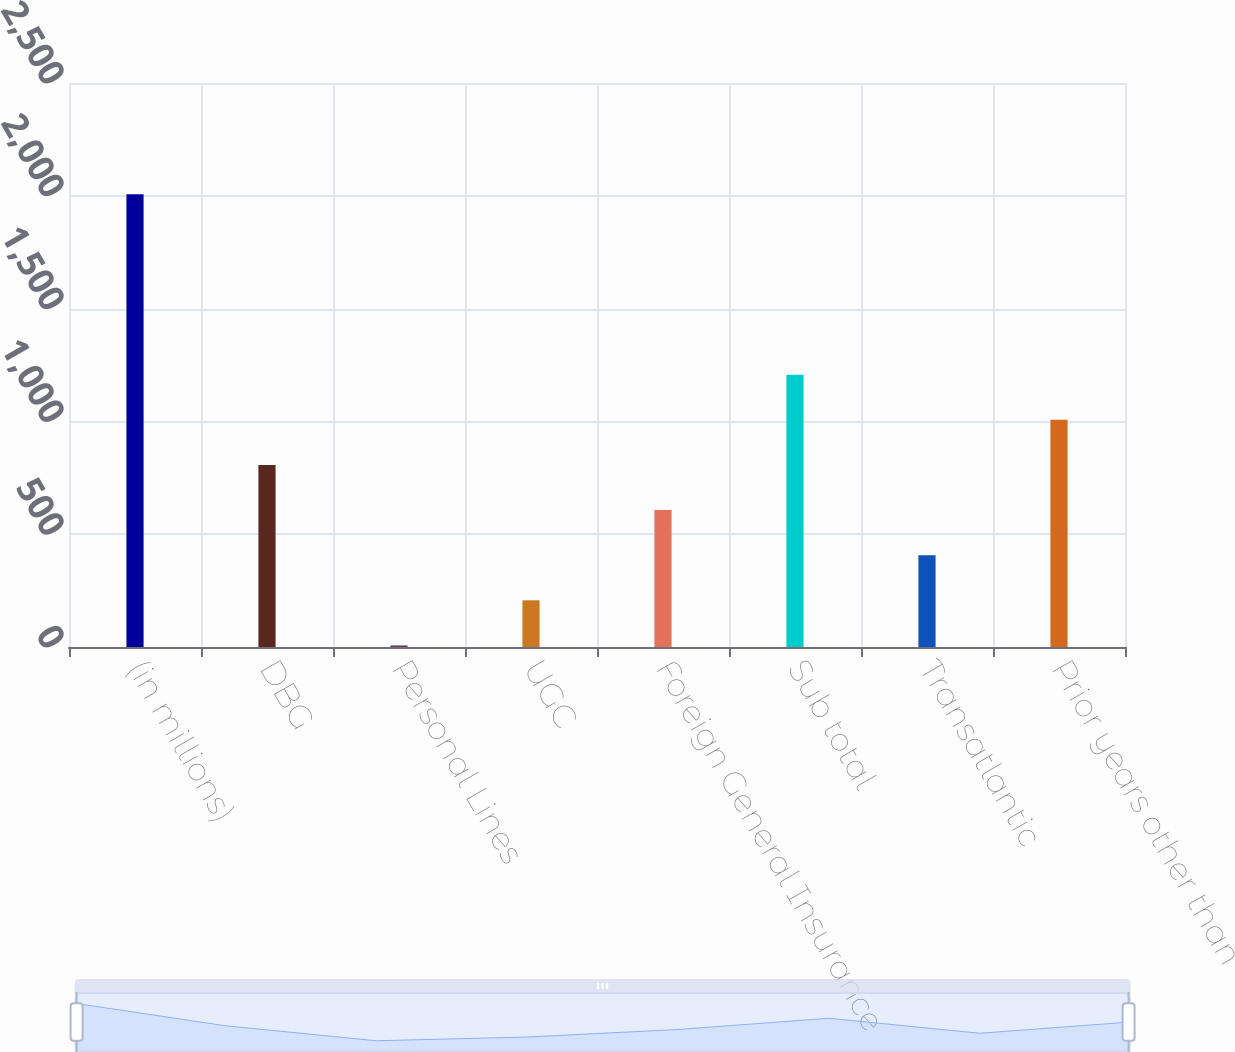Convert chart. <chart><loc_0><loc_0><loc_500><loc_500><bar_chart><fcel>(in millions)<fcel>DBG<fcel>Personal Lines<fcel>UGC<fcel>Foreign General Insurance<fcel>Sub total<fcel>Transatlantic<fcel>Prior years other than<nl><fcel>2007<fcel>807<fcel>7<fcel>207<fcel>607<fcel>1207<fcel>407<fcel>1007<nl></chart> 